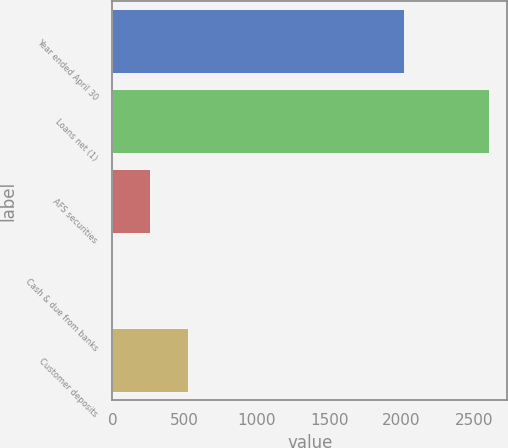<chart> <loc_0><loc_0><loc_500><loc_500><bar_chart><fcel>Year ended April 30<fcel>Loans net (1)<fcel>AFS securities<fcel>Cash & due from banks<fcel>Customer deposits<nl><fcel>2014<fcel>2603<fcel>263<fcel>3<fcel>523<nl></chart> 